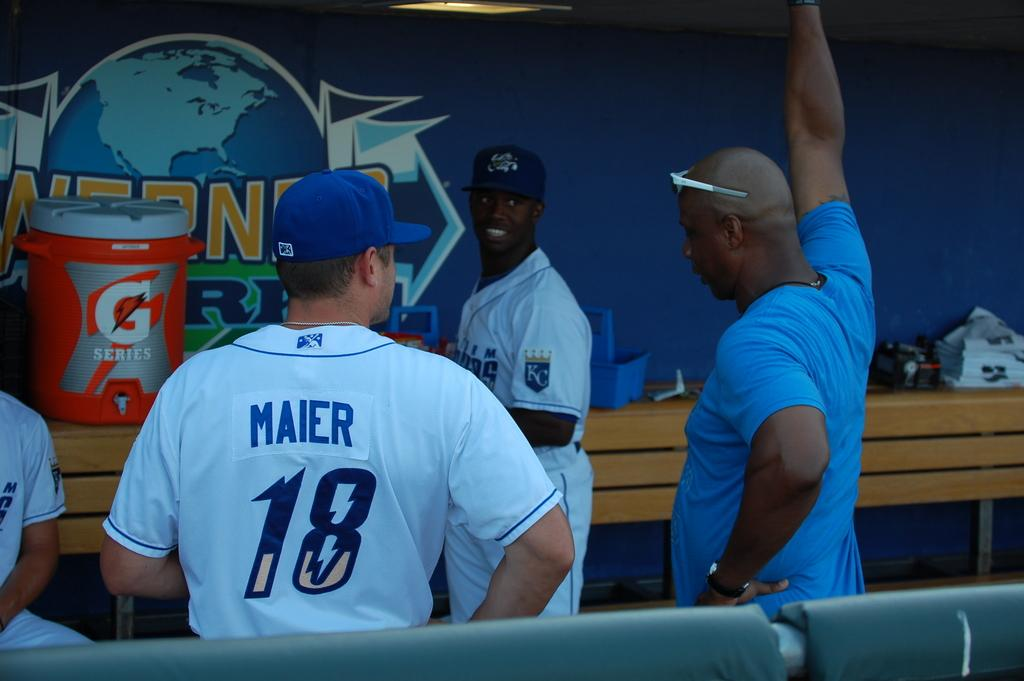<image>
Create a compact narrative representing the image presented. G series is advertised on the tub which is red and grey. 